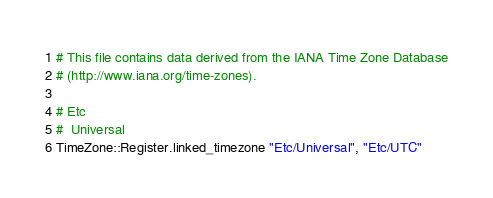Convert code to text. <code><loc_0><loc_0><loc_500><loc_500><_Crystal_># This file contains data derived from the IANA Time Zone Database
# (http://www.iana.org/time-zones).

# Etc
#  Universal
TimeZone::Register.linked_timezone "Etc/Universal", "Etc/UTC"
</code> 